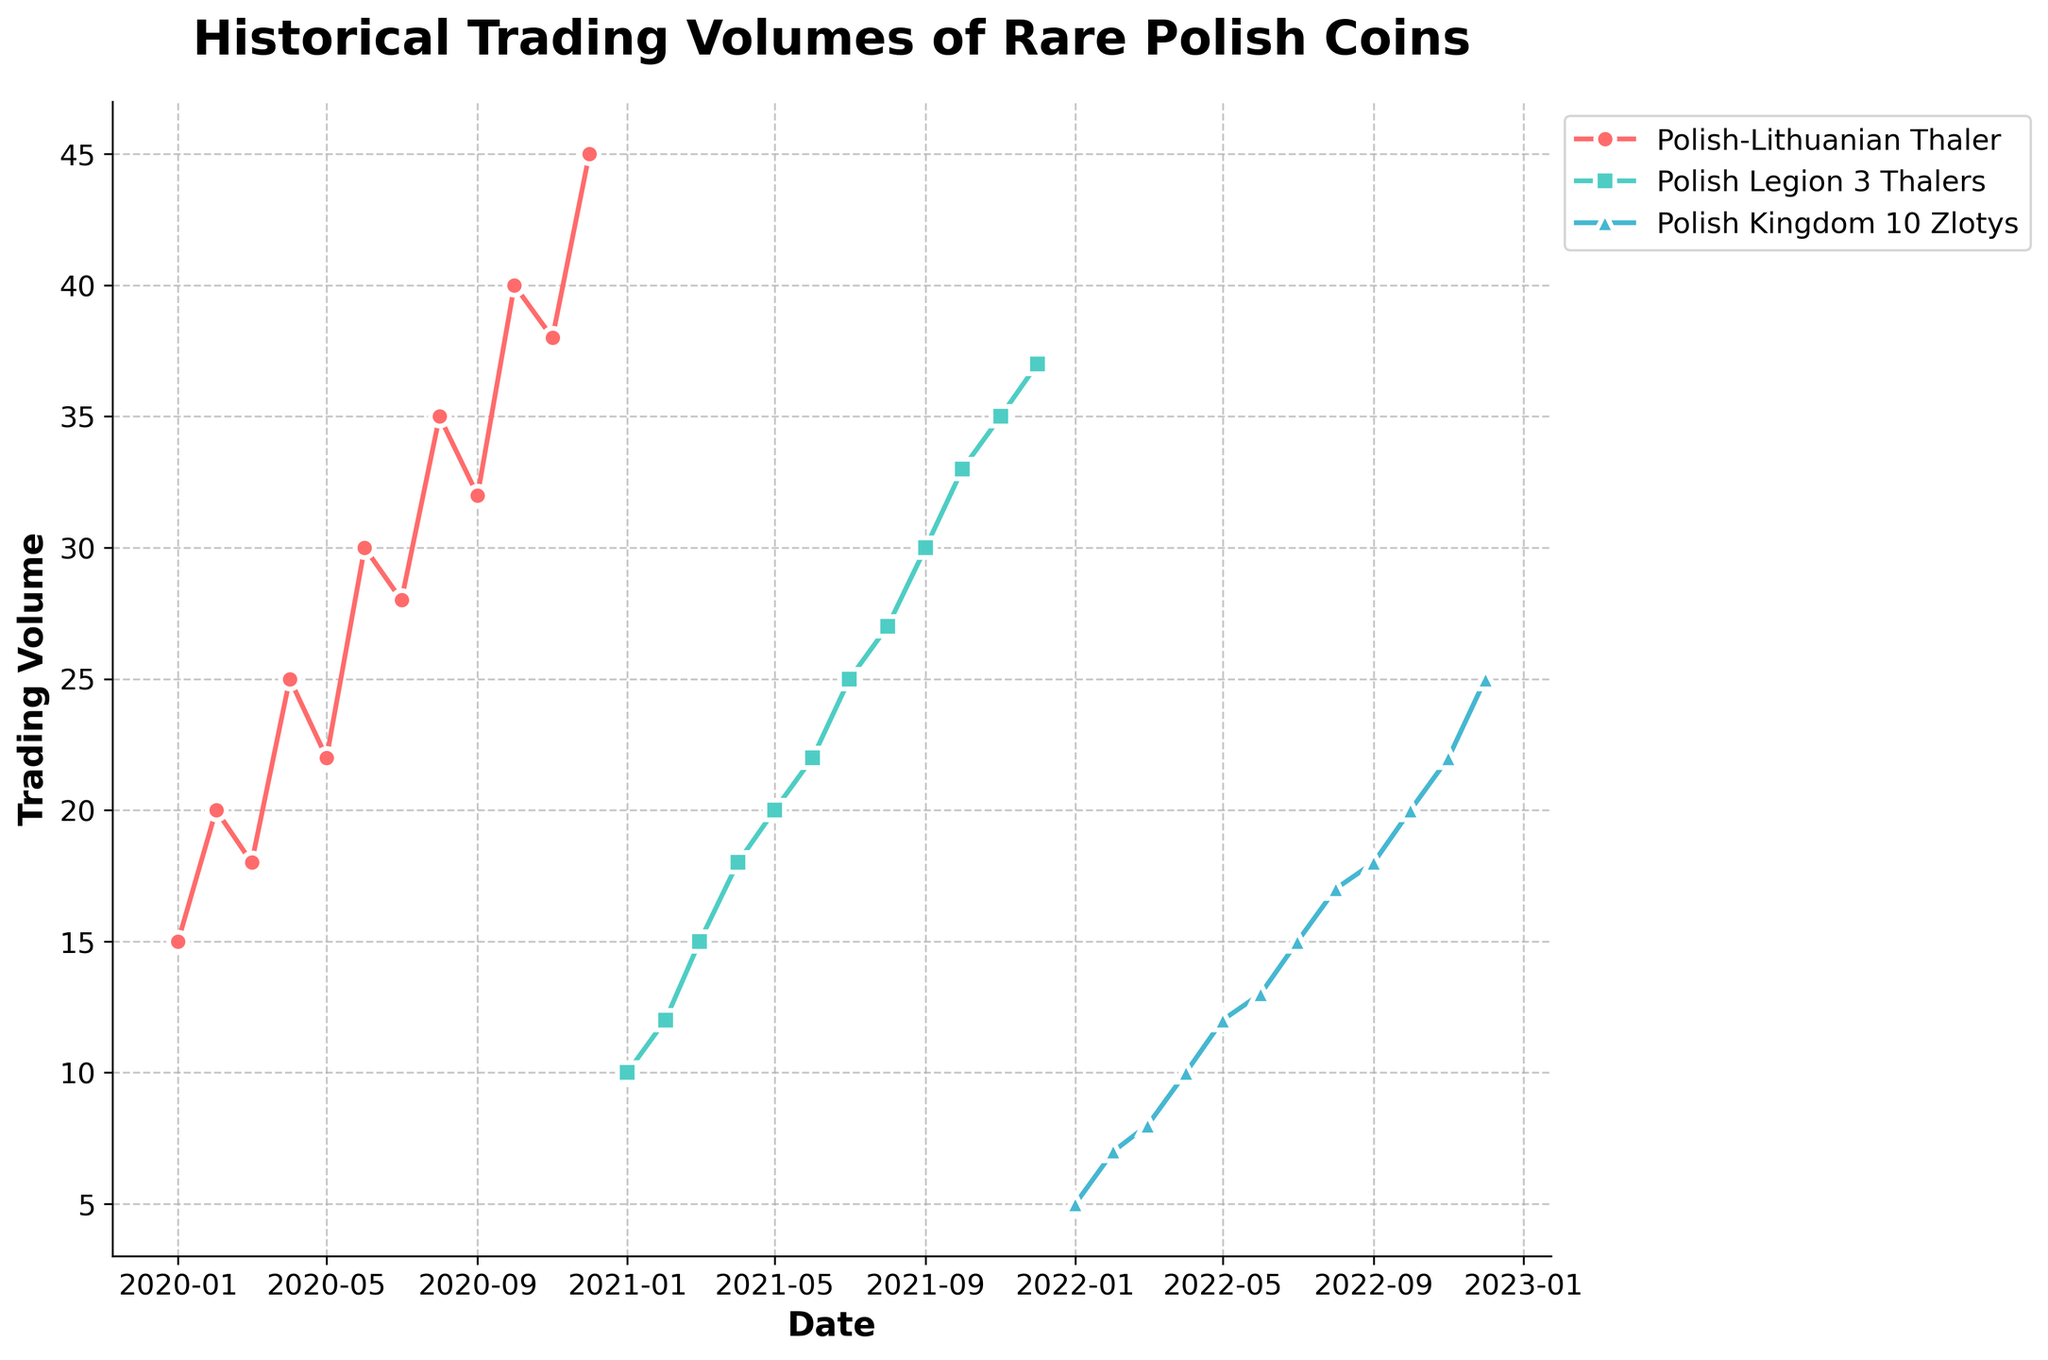How many different collectible coins are represented in the plot? First, analyze the title and legend of the figure. The legend shows that there are three different collectible coins: Polish-Lithuanian Thaler, Polish Legion 3 Thalers, and Polish Kingdom 10 Zlotys.
Answer: Three What is the title of the figure? The title of the figure is explicitly mentioned at the top of the chart to describe what the graph represents. The title reads: 'Historical Trading Volumes of Rare Polish Coins'.
Answer: Historical Trading Volumes of Rare Polish Coins Between which months does the trading volume of the "Polish-Lithuanian Thaler" increase the most? Observe the plotted line for the "Polish-Lithuanian Thaler" in terms of highest vertical change between consecutive points. The steepest increase occurs between October 2020 (Trading Volume = 40) and November 2020 (Trading Volume = 38).
Answer: October to November What is the trading volume of "Polish Kingdom 10 Zlotys" in December 2022? Locate December 2022 on the x-axis and find the corresponding value of the "Polish Kingdom 10 Zlotys" line. The trading volume indicated there is 25.
Answer: 25 Which coin's trading volume sees the highest increase over the entire period? Compare the initial and final trading volumes for each coin to determine the total increase. "Polish-Lithuanian Thaler" starts at 15 and ends at 45, "Polish Legion 3 Thalers" starts at 10 and ends at 37, and "Polish Kingdom 10 Zlotys" starts at 5 and ends at 25. The "Polish-Lithuanian Thaler" has the highest increase (45 - 15 = 30).
Answer: Polish-Lithuanian Thaler During which month does the "Polish-Lithuanian Thaler" reach its highest trading volume? The highest point on the plot line for "Polish-Lithuanian Thaler" visually represents the highest trading volume. It occurs in December 2020 with a trading volume of 45.
Answer: December 2020 What is the difference in trading volumes for "Polish Legion 3 Thalers" in June 2021 and November 2021? Identify the trading volumes for the two given months and subtract. Trading volume in June 2021 is 22, and in November 2021, it's 35. The difference is 35 - 22 = 13.
Answer: 13 How many data points are plotted for "Polish Kingdom 10 Zlotys"? Observe the line graph and count the number of data markers present. For "Polish Kingdom 10 Zlotys", there are 12 monthly points (one for each month in a year).
Answer: 12 Which coin consistently shows a monthly increase in trading volume over the entire period? Examine each coin's plot line to see if it continually rises without any dips. The "Polish Kingdom 10 Zlotys" shows a steady increase in trading volume every month over the entire observed period.
Answer: Polish Kingdom 10 Zlotys What is the overall trend for the trading volume of the "Polish-Lithuanian Thaler" from January 2020 to December 2020? Follow the plot line for "Polish-Lithuanian Thaler" from start to end date within the given year. The overall trend shows an increase from the starting volume of 15 to 45 by the end of the year.
Answer: Increasing 